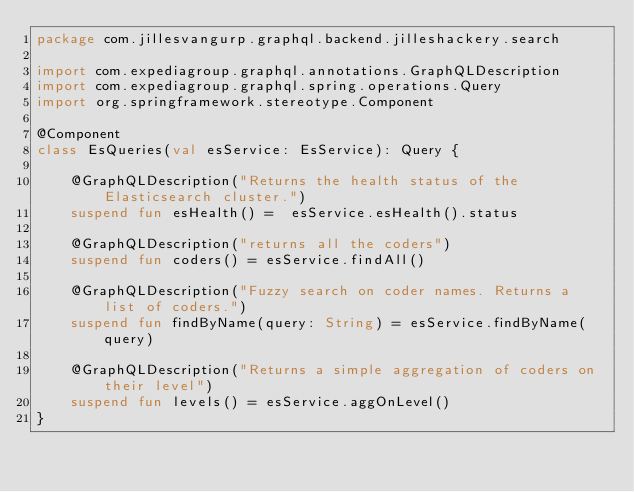Convert code to text. <code><loc_0><loc_0><loc_500><loc_500><_Kotlin_>package com.jillesvangurp.graphql.backend.jilleshackery.search

import com.expediagroup.graphql.annotations.GraphQLDescription
import com.expediagroup.graphql.spring.operations.Query
import org.springframework.stereotype.Component

@Component
class EsQueries(val esService: EsService): Query {

    @GraphQLDescription("Returns the health status of the Elasticsearch cluster.")
    suspend fun esHealth() =  esService.esHealth().status

    @GraphQLDescription("returns all the coders")
    suspend fun coders() = esService.findAll()

    @GraphQLDescription("Fuzzy search on coder names. Returns a list of coders.")
    suspend fun findByName(query: String) = esService.findByName(query)

    @GraphQLDescription("Returns a simple aggregation of coders on their level")
    suspend fun levels() = esService.aggOnLevel()
}

</code> 